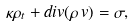<formula> <loc_0><loc_0><loc_500><loc_500>\kappa \rho _ { t } + d i v ( \rho \, v ) = \sigma ,</formula> 